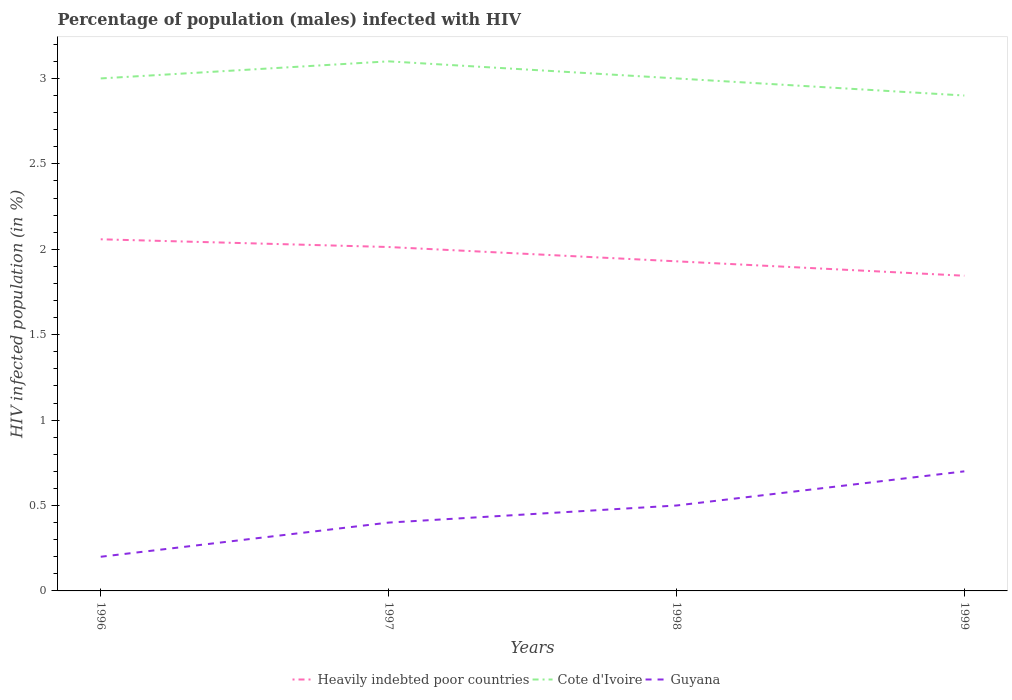How many different coloured lines are there?
Make the answer very short. 3. Is the number of lines equal to the number of legend labels?
Provide a succinct answer. Yes. Across all years, what is the maximum percentage of HIV infected male population in Heavily indebted poor countries?
Give a very brief answer. 1.85. What is the total percentage of HIV infected male population in Cote d'Ivoire in the graph?
Give a very brief answer. -0.1. What is the difference between the highest and the second highest percentage of HIV infected male population in Guyana?
Your answer should be compact. 0.5. Is the percentage of HIV infected male population in Heavily indebted poor countries strictly greater than the percentage of HIV infected male population in Cote d'Ivoire over the years?
Offer a very short reply. Yes. Are the values on the major ticks of Y-axis written in scientific E-notation?
Your response must be concise. No. How many legend labels are there?
Your response must be concise. 3. What is the title of the graph?
Your answer should be very brief. Percentage of population (males) infected with HIV. Does "Swaziland" appear as one of the legend labels in the graph?
Make the answer very short. No. What is the label or title of the Y-axis?
Provide a short and direct response. HIV infected population (in %). What is the HIV infected population (in %) of Heavily indebted poor countries in 1996?
Give a very brief answer. 2.06. What is the HIV infected population (in %) of Heavily indebted poor countries in 1997?
Make the answer very short. 2.01. What is the HIV infected population (in %) of Heavily indebted poor countries in 1998?
Give a very brief answer. 1.93. What is the HIV infected population (in %) of Cote d'Ivoire in 1998?
Provide a short and direct response. 3. What is the HIV infected population (in %) in Heavily indebted poor countries in 1999?
Your answer should be very brief. 1.85. What is the HIV infected population (in %) of Cote d'Ivoire in 1999?
Give a very brief answer. 2.9. What is the HIV infected population (in %) of Guyana in 1999?
Give a very brief answer. 0.7. Across all years, what is the maximum HIV infected population (in %) of Heavily indebted poor countries?
Your answer should be very brief. 2.06. Across all years, what is the maximum HIV infected population (in %) of Cote d'Ivoire?
Your answer should be very brief. 3.1. Across all years, what is the minimum HIV infected population (in %) of Heavily indebted poor countries?
Offer a terse response. 1.85. Across all years, what is the minimum HIV infected population (in %) of Cote d'Ivoire?
Keep it short and to the point. 2.9. Across all years, what is the minimum HIV infected population (in %) in Guyana?
Make the answer very short. 0.2. What is the total HIV infected population (in %) in Heavily indebted poor countries in the graph?
Provide a short and direct response. 7.85. What is the total HIV infected population (in %) of Cote d'Ivoire in the graph?
Provide a short and direct response. 12. What is the total HIV infected population (in %) of Guyana in the graph?
Keep it short and to the point. 1.8. What is the difference between the HIV infected population (in %) of Heavily indebted poor countries in 1996 and that in 1997?
Your answer should be compact. 0.05. What is the difference between the HIV infected population (in %) of Cote d'Ivoire in 1996 and that in 1997?
Give a very brief answer. -0.1. What is the difference between the HIV infected population (in %) of Heavily indebted poor countries in 1996 and that in 1998?
Provide a short and direct response. 0.13. What is the difference between the HIV infected population (in %) in Heavily indebted poor countries in 1996 and that in 1999?
Provide a short and direct response. 0.21. What is the difference between the HIV infected population (in %) of Cote d'Ivoire in 1996 and that in 1999?
Ensure brevity in your answer.  0.1. What is the difference between the HIV infected population (in %) of Guyana in 1996 and that in 1999?
Make the answer very short. -0.5. What is the difference between the HIV infected population (in %) of Heavily indebted poor countries in 1997 and that in 1998?
Offer a terse response. 0.08. What is the difference between the HIV infected population (in %) in Cote d'Ivoire in 1997 and that in 1998?
Give a very brief answer. 0.1. What is the difference between the HIV infected population (in %) in Heavily indebted poor countries in 1997 and that in 1999?
Your response must be concise. 0.17. What is the difference between the HIV infected population (in %) of Cote d'Ivoire in 1997 and that in 1999?
Provide a succinct answer. 0.2. What is the difference between the HIV infected population (in %) in Guyana in 1997 and that in 1999?
Provide a succinct answer. -0.3. What is the difference between the HIV infected population (in %) of Heavily indebted poor countries in 1998 and that in 1999?
Make the answer very short. 0.08. What is the difference between the HIV infected population (in %) of Cote d'Ivoire in 1998 and that in 1999?
Ensure brevity in your answer.  0.1. What is the difference between the HIV infected population (in %) in Guyana in 1998 and that in 1999?
Your answer should be compact. -0.2. What is the difference between the HIV infected population (in %) of Heavily indebted poor countries in 1996 and the HIV infected population (in %) of Cote d'Ivoire in 1997?
Provide a succinct answer. -1.04. What is the difference between the HIV infected population (in %) of Heavily indebted poor countries in 1996 and the HIV infected population (in %) of Guyana in 1997?
Your answer should be very brief. 1.66. What is the difference between the HIV infected population (in %) in Heavily indebted poor countries in 1996 and the HIV infected population (in %) in Cote d'Ivoire in 1998?
Keep it short and to the point. -0.94. What is the difference between the HIV infected population (in %) of Heavily indebted poor countries in 1996 and the HIV infected population (in %) of Guyana in 1998?
Your response must be concise. 1.56. What is the difference between the HIV infected population (in %) in Cote d'Ivoire in 1996 and the HIV infected population (in %) in Guyana in 1998?
Your answer should be compact. 2.5. What is the difference between the HIV infected population (in %) in Heavily indebted poor countries in 1996 and the HIV infected population (in %) in Cote d'Ivoire in 1999?
Give a very brief answer. -0.84. What is the difference between the HIV infected population (in %) in Heavily indebted poor countries in 1996 and the HIV infected population (in %) in Guyana in 1999?
Keep it short and to the point. 1.36. What is the difference between the HIV infected population (in %) of Heavily indebted poor countries in 1997 and the HIV infected population (in %) of Cote d'Ivoire in 1998?
Provide a succinct answer. -0.99. What is the difference between the HIV infected population (in %) in Heavily indebted poor countries in 1997 and the HIV infected population (in %) in Guyana in 1998?
Offer a very short reply. 1.51. What is the difference between the HIV infected population (in %) in Heavily indebted poor countries in 1997 and the HIV infected population (in %) in Cote d'Ivoire in 1999?
Give a very brief answer. -0.89. What is the difference between the HIV infected population (in %) of Heavily indebted poor countries in 1997 and the HIV infected population (in %) of Guyana in 1999?
Offer a very short reply. 1.31. What is the difference between the HIV infected population (in %) of Heavily indebted poor countries in 1998 and the HIV infected population (in %) of Cote d'Ivoire in 1999?
Provide a succinct answer. -0.97. What is the difference between the HIV infected population (in %) in Heavily indebted poor countries in 1998 and the HIV infected population (in %) in Guyana in 1999?
Provide a succinct answer. 1.23. What is the difference between the HIV infected population (in %) in Cote d'Ivoire in 1998 and the HIV infected population (in %) in Guyana in 1999?
Ensure brevity in your answer.  2.3. What is the average HIV infected population (in %) of Heavily indebted poor countries per year?
Ensure brevity in your answer.  1.96. What is the average HIV infected population (in %) in Guyana per year?
Keep it short and to the point. 0.45. In the year 1996, what is the difference between the HIV infected population (in %) of Heavily indebted poor countries and HIV infected population (in %) of Cote d'Ivoire?
Provide a succinct answer. -0.94. In the year 1996, what is the difference between the HIV infected population (in %) in Heavily indebted poor countries and HIV infected population (in %) in Guyana?
Offer a terse response. 1.86. In the year 1996, what is the difference between the HIV infected population (in %) of Cote d'Ivoire and HIV infected population (in %) of Guyana?
Offer a terse response. 2.8. In the year 1997, what is the difference between the HIV infected population (in %) in Heavily indebted poor countries and HIV infected population (in %) in Cote d'Ivoire?
Keep it short and to the point. -1.09. In the year 1997, what is the difference between the HIV infected population (in %) in Heavily indebted poor countries and HIV infected population (in %) in Guyana?
Your answer should be very brief. 1.61. In the year 1997, what is the difference between the HIV infected population (in %) in Cote d'Ivoire and HIV infected population (in %) in Guyana?
Offer a terse response. 2.7. In the year 1998, what is the difference between the HIV infected population (in %) in Heavily indebted poor countries and HIV infected population (in %) in Cote d'Ivoire?
Your answer should be very brief. -1.07. In the year 1998, what is the difference between the HIV infected population (in %) in Heavily indebted poor countries and HIV infected population (in %) in Guyana?
Offer a terse response. 1.43. In the year 1999, what is the difference between the HIV infected population (in %) in Heavily indebted poor countries and HIV infected population (in %) in Cote d'Ivoire?
Your answer should be compact. -1.05. In the year 1999, what is the difference between the HIV infected population (in %) of Heavily indebted poor countries and HIV infected population (in %) of Guyana?
Your answer should be compact. 1.15. In the year 1999, what is the difference between the HIV infected population (in %) of Cote d'Ivoire and HIV infected population (in %) of Guyana?
Keep it short and to the point. 2.2. What is the ratio of the HIV infected population (in %) in Heavily indebted poor countries in 1996 to that in 1997?
Keep it short and to the point. 1.02. What is the ratio of the HIV infected population (in %) of Guyana in 1996 to that in 1997?
Keep it short and to the point. 0.5. What is the ratio of the HIV infected population (in %) in Heavily indebted poor countries in 1996 to that in 1998?
Provide a short and direct response. 1.07. What is the ratio of the HIV infected population (in %) of Heavily indebted poor countries in 1996 to that in 1999?
Provide a short and direct response. 1.12. What is the ratio of the HIV infected population (in %) in Cote d'Ivoire in 1996 to that in 1999?
Give a very brief answer. 1.03. What is the ratio of the HIV infected population (in %) in Guyana in 1996 to that in 1999?
Offer a very short reply. 0.29. What is the ratio of the HIV infected population (in %) in Heavily indebted poor countries in 1997 to that in 1998?
Give a very brief answer. 1.04. What is the ratio of the HIV infected population (in %) in Heavily indebted poor countries in 1997 to that in 1999?
Your response must be concise. 1.09. What is the ratio of the HIV infected population (in %) in Cote d'Ivoire in 1997 to that in 1999?
Provide a short and direct response. 1.07. What is the ratio of the HIV infected population (in %) in Heavily indebted poor countries in 1998 to that in 1999?
Offer a very short reply. 1.05. What is the ratio of the HIV infected population (in %) in Cote d'Ivoire in 1998 to that in 1999?
Ensure brevity in your answer.  1.03. What is the difference between the highest and the second highest HIV infected population (in %) of Heavily indebted poor countries?
Keep it short and to the point. 0.05. What is the difference between the highest and the second highest HIV infected population (in %) of Cote d'Ivoire?
Make the answer very short. 0.1. What is the difference between the highest and the lowest HIV infected population (in %) of Heavily indebted poor countries?
Provide a short and direct response. 0.21. 